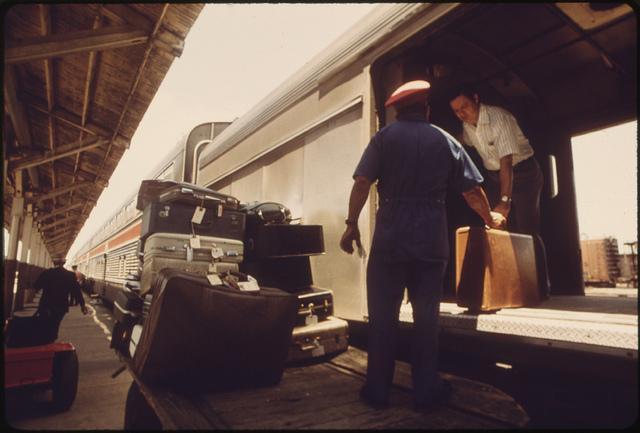How many red cases are there?
Give a very brief answer. 1. How many suitcases are visible?
Give a very brief answer. 8. How many people can be seen?
Give a very brief answer. 3. 